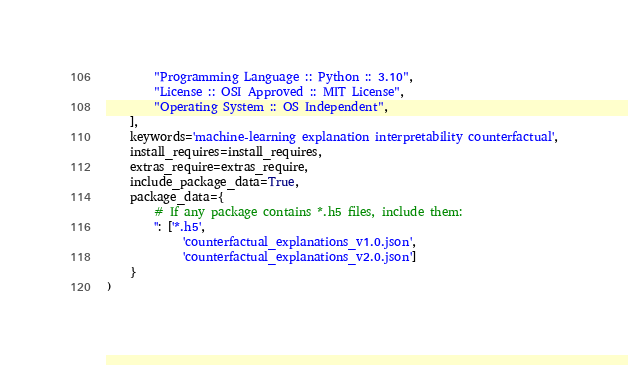Convert code to text. <code><loc_0><loc_0><loc_500><loc_500><_Python_>        "Programming Language :: Python :: 3.10",
        "License :: OSI Approved :: MIT License",
        "Operating System :: OS Independent",
    ],
    keywords='machine-learning explanation interpretability counterfactual',
    install_requires=install_requires,
    extras_require=extras_require,
    include_package_data=True,
    package_data={
        # If any package contains *.h5 files, include them:
        '': ['*.h5',
             'counterfactual_explanations_v1.0.json',
             'counterfactual_explanations_v2.0.json']
    }
)
</code> 